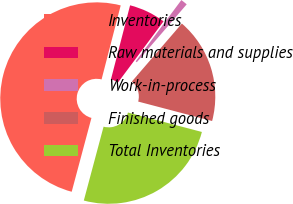Convert chart to OTSL. <chart><loc_0><loc_0><loc_500><loc_500><pie_chart><fcel>Inventories<fcel>Raw materials and supplies<fcel>Work-in-process<fcel>Finished goods<fcel>Total Inventories<nl><fcel>49.87%<fcel>6.17%<fcel>1.13%<fcel>17.77%<fcel>25.07%<nl></chart> 